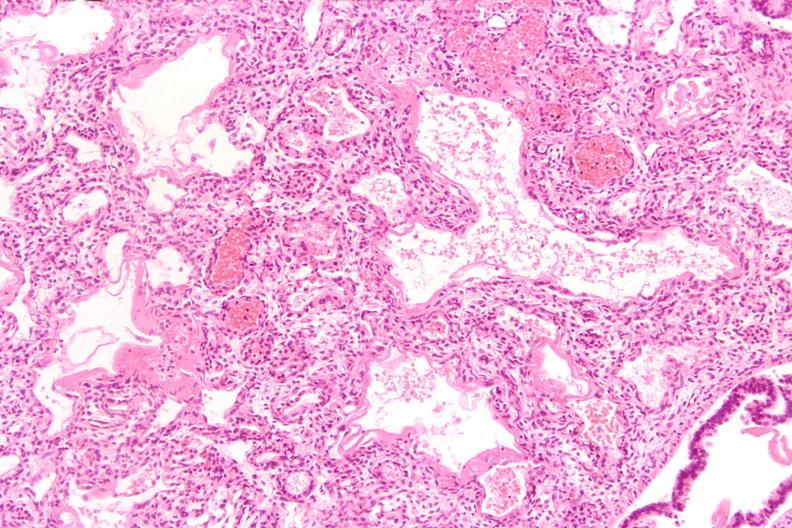what does this image show?
Answer the question using a single word or phrase. Lungs 